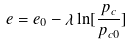Convert formula to latex. <formula><loc_0><loc_0><loc_500><loc_500>e = e _ { 0 } - \lambda \ln [ \frac { p _ { c } } { p _ { c 0 } } ]</formula> 